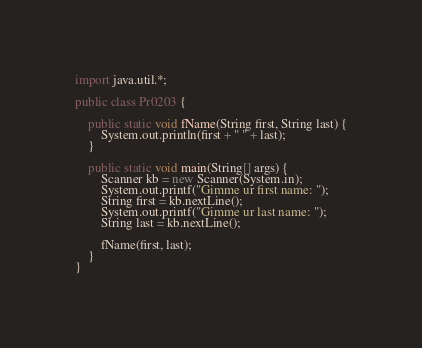<code> <loc_0><loc_0><loc_500><loc_500><_Java_>import java.util.*;

public class Pr0203 {

	public static void fName(String first, String last) {
		System.out.println(first + " " + last);
	}

	public static void main(String[] args) {
		Scanner kb = new Scanner(System.in);
		System.out.printf("Gimme ur first name: ");
		String first = kb.nextLine();
		System.out.printf("Gimme ur last name: ");
		String last = kb.nextLine();

		fName(first, last);
	}
}</code> 